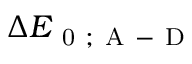<formula> <loc_0><loc_0><loc_500><loc_500>\Delta E _ { 0 ; A - D }</formula> 